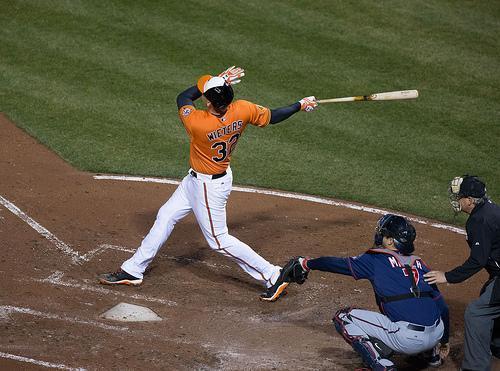How many people are swinging a baseball bat?
Give a very brief answer. 1. 